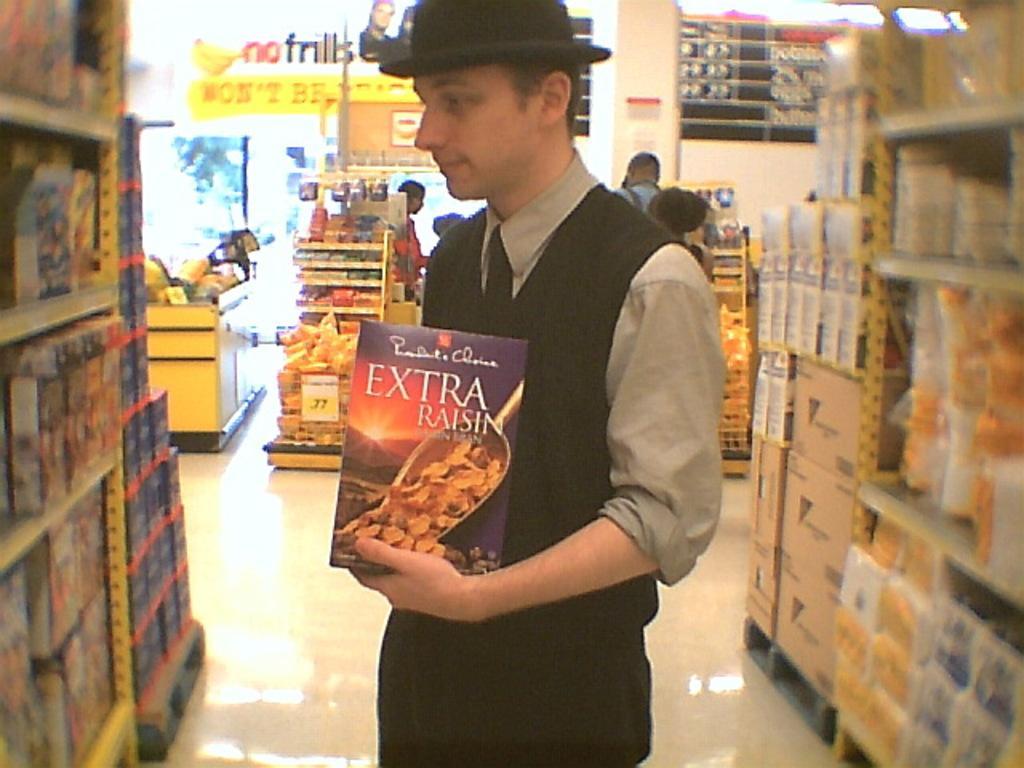Could you give a brief overview of what you see in this image? In this image I can see a man is in the supermarket, he is holding a box in her hand. He wore black color hat, tie, trouser. 